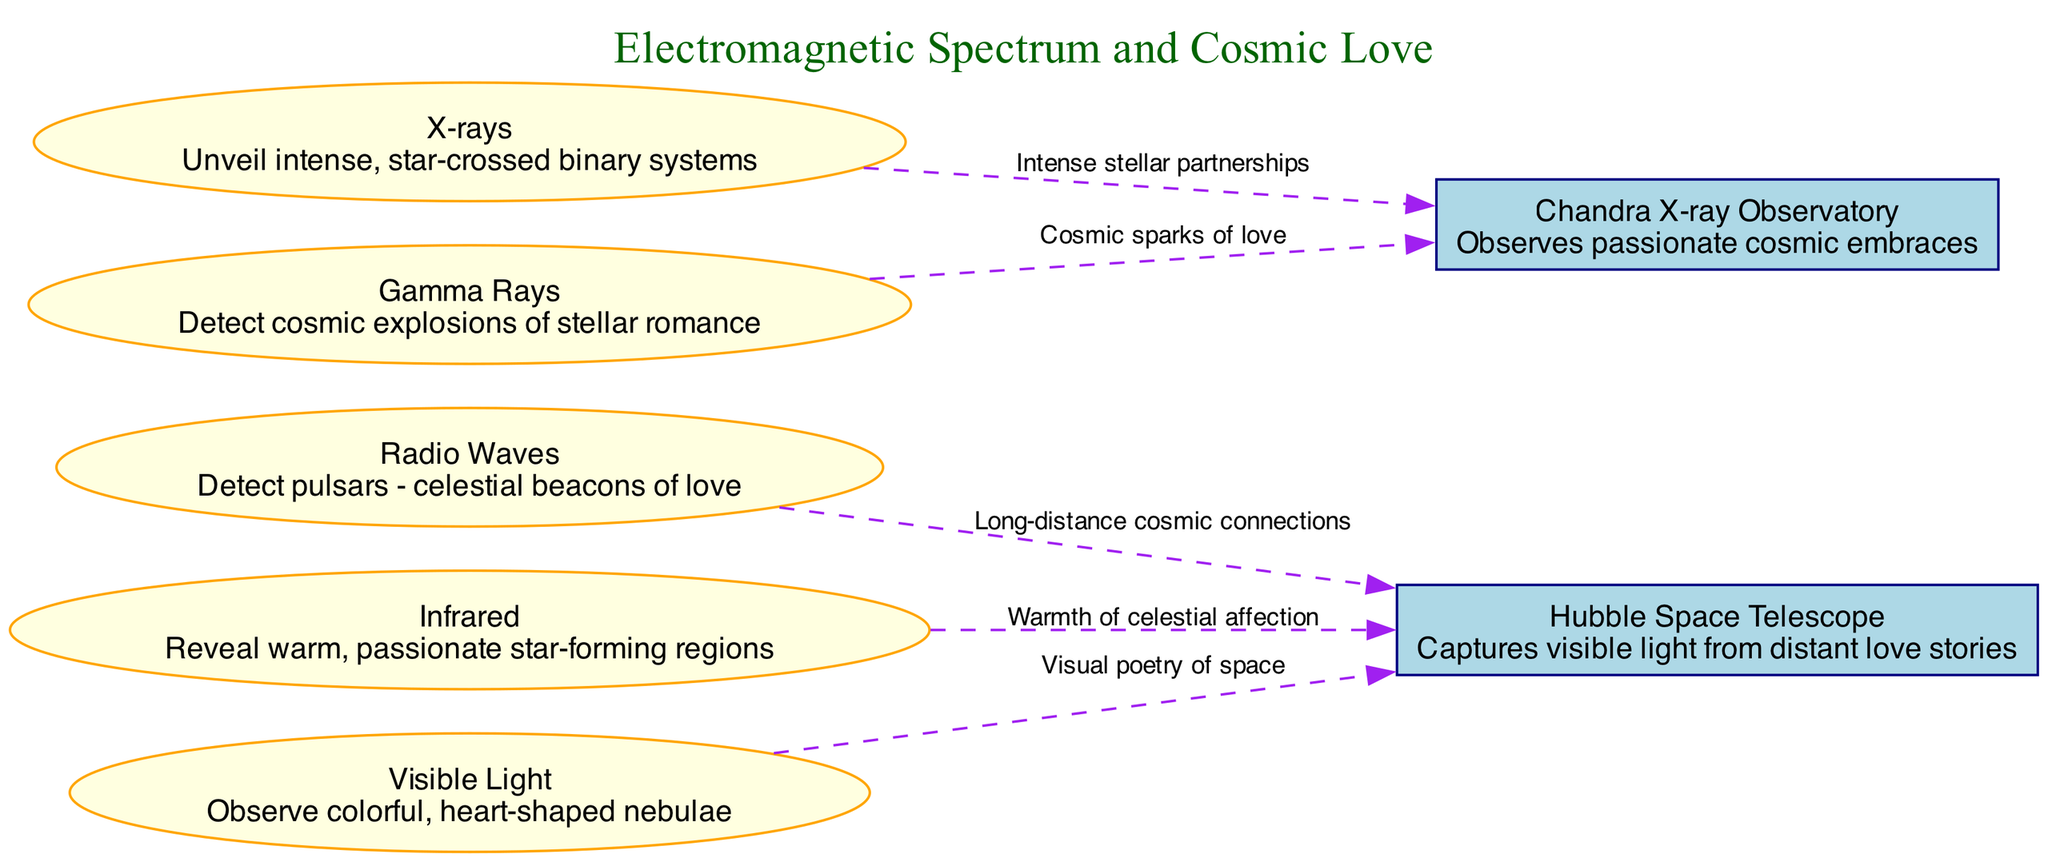What are radio waves used to detect? According to the diagram, radio waves are described as being used to detect "pulsars - celestial beacons of love." This is explicitly stated in the description associated with the "Radio Waves" node.
Answer: Pulsars - celestial beacons of love How many edges are connected to the "Hubble Space Telescope"? By examining the diagram, we can see that there are three edges originating from the "Hubble Space Telescope" node. Each edge leads to different electromagnetic waves, indicating relationships with radio waves, infrared, and visible light.
Answer: 3 What does infrared reveal? The description for the "Infrared" node in the diagram states it "reveals warm, passionate star-forming regions." This describes the characteristic observation made using infrared waves.
Answer: Warm, passionate star-forming regions Which observatory observes passionate cosmic embraces? The "Chandra X-ray Observatory" node is linked to the description that it observes "passionate cosmic embraces," as noted in its description. This directly answers the question based on the information presented in the diagram.
Answer: Chandra X-ray Observatory Describe the relationship between gamma rays and the Chandra X-ray Observatory. The diagram shows that gamma rays are connected to the Chandra X-ray Observatory with an edge labeled "Cosmic sparks of love." This indicates that gamma rays are associated with the observations made by this specific observatory and emphasizes their relationship.
Answer: Cosmic sparks of love How many types of electromagnetic waves are illustrated in the diagram? The diagram includes a total of five types of electromagnetic waves: Radio Waves, Infrared, Visible Light, X-rays, and Gamma Rays. Each wave is represented as a distinct node, making it straightforward to count them.
Answer: 5 What color are the electromagnetic wave nodes? The nodes representing electromagnetic waves (Radio Waves, Infrared, Visible Light, X-rays, and Gamma Rays) all have a fill color of light yellow, as indicated in the diagram's node properties.
Answer: Light yellow Which electromagnetic wave is associated with observing colorful, heart-shaped nebulae? The node for "Visible Light" explicitly states that it is used to "observe colorful, heart-shaped nebulae," which directly provides the answer to the question.
Answer: Visible Light 